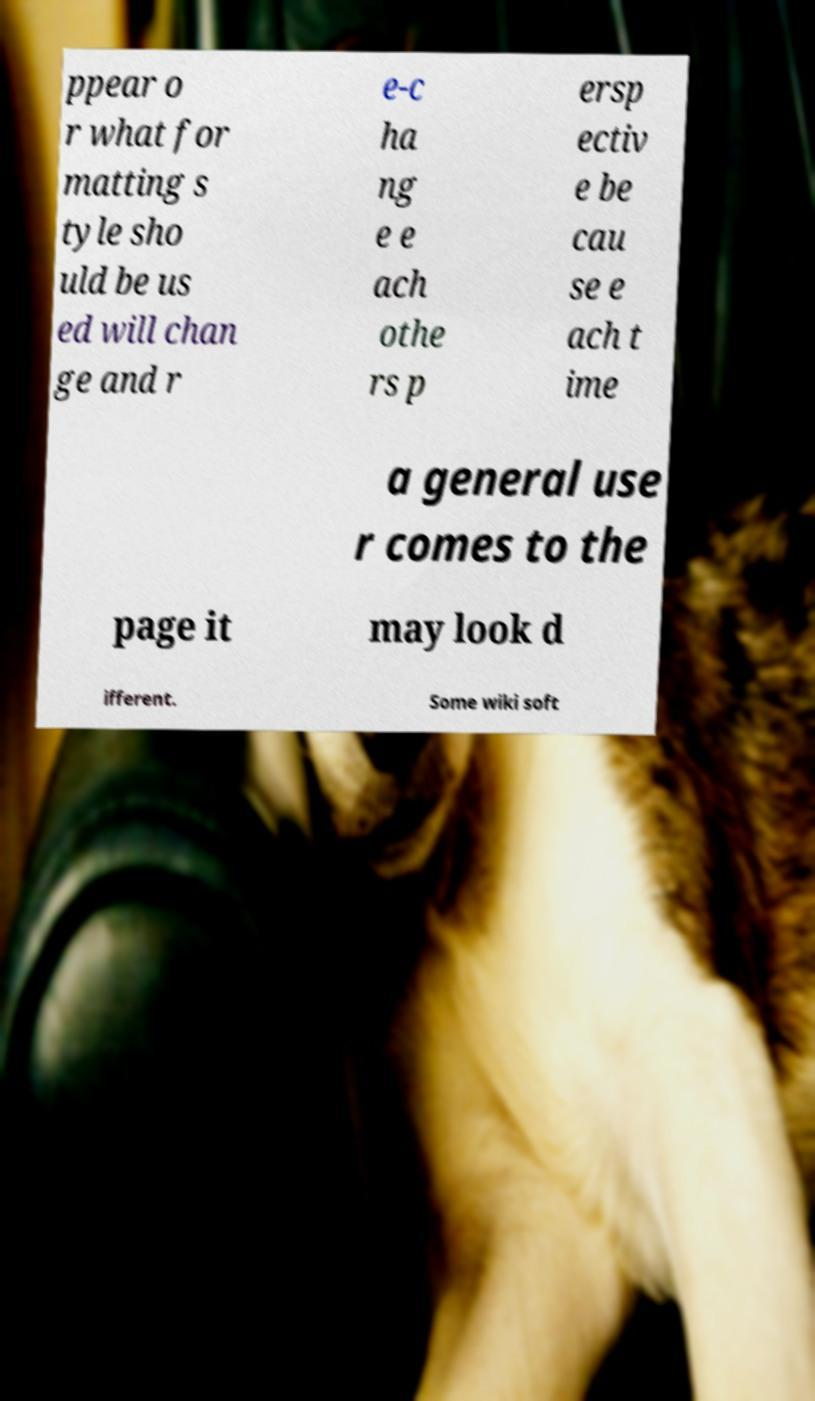Could you extract and type out the text from this image? ppear o r what for matting s tyle sho uld be us ed will chan ge and r e-c ha ng e e ach othe rs p ersp ectiv e be cau se e ach t ime a general use r comes to the page it may look d ifferent. Some wiki soft 